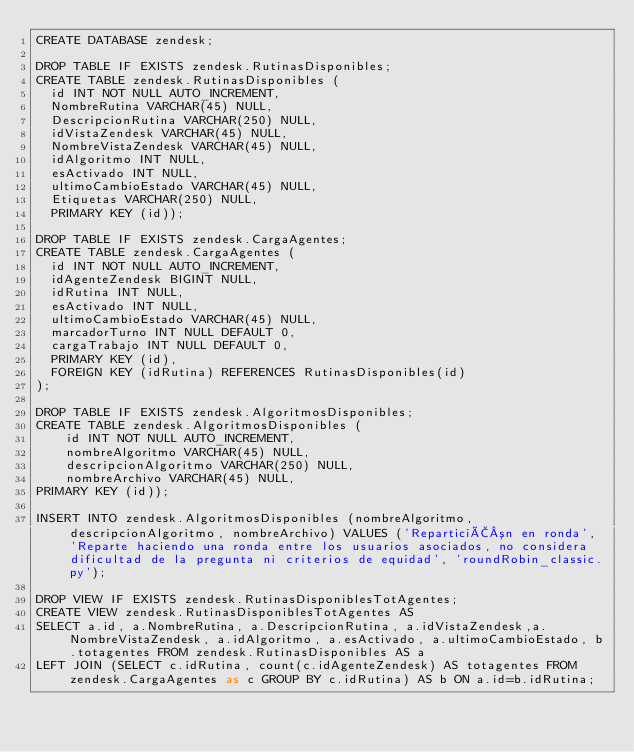Convert code to text. <code><loc_0><loc_0><loc_500><loc_500><_SQL_>CREATE DATABASE zendesk;

DROP TABLE IF EXISTS zendesk.RutinasDisponibles;
CREATE TABLE zendesk.RutinasDisponibles (
  id INT NOT NULL AUTO_INCREMENT,
  NombreRutina VARCHAR(45) NULL,
  DescripcionRutina VARCHAR(250) NULL,
  idVistaZendesk VARCHAR(45) NULL,
  NombreVistaZendesk VARCHAR(45) NULL,
  idAlgoritmo INT NULL,
  esActivado INT NULL,
  ultimoCambioEstado VARCHAR(45) NULL,
  Etiquetas VARCHAR(250) NULL,
  PRIMARY KEY (id));

DROP TABLE IF EXISTS zendesk.CargaAgentes;
CREATE TABLE zendesk.CargaAgentes (
  id INT NOT NULL AUTO_INCREMENT,
  idAgenteZendesk BIGINT NULL,
  idRutina INT NULL,
  esActivado INT NULL,
  ultimoCambioEstado VARCHAR(45) NULL,
  marcadorTurno INT NULL DEFAULT 0,
  cargaTrabajo INT NULL DEFAULT 0,
  PRIMARY KEY (id),
  FOREIGN KEY (idRutina) REFERENCES RutinasDisponibles(id)
);

DROP TABLE IF EXISTS zendesk.AlgoritmosDisponibles;
CREATE TABLE zendesk.AlgoritmosDisponibles (
	id INT NOT NULL AUTO_INCREMENT,
	nombreAlgoritmo VARCHAR(45) NULL,
	descripcionAlgoritmo VARCHAR(250) NULL,
	nombreArchivo VARCHAR(45) NULL,
PRIMARY KEY (id));

INSERT INTO zendesk.AlgoritmosDisponibles (nombreAlgoritmo, descripcionAlgoritmo, nombreArchivo) VALUES ('ReparticiÃ³n en ronda', 'Reparte haciendo una ronda entre los usuarios asociados, no considera dificultad de la pregunta ni criterios de equidad', 'roundRobin_classic.py');

DROP VIEW IF EXISTS zendesk.RutinasDisponiblesTotAgentes;
CREATE VIEW zendesk.RutinasDisponiblesTotAgentes AS
SELECT a.id, a.NombreRutina, a.DescripcionRutina, a.idVistaZendesk,a.NombreVistaZendesk, a.idAlgoritmo, a.esActivado, a.ultimoCambioEstado, b.totagentes FROM zendesk.RutinasDisponibles AS a
LEFT JOIN (SELECT c.idRutina, count(c.idAgenteZendesk) AS totagentes FROM zendesk.CargaAgentes as c GROUP BY c.idRutina) AS b ON a.id=b.idRutina;
</code> 